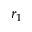<formula> <loc_0><loc_0><loc_500><loc_500>r _ { 1 }</formula> 